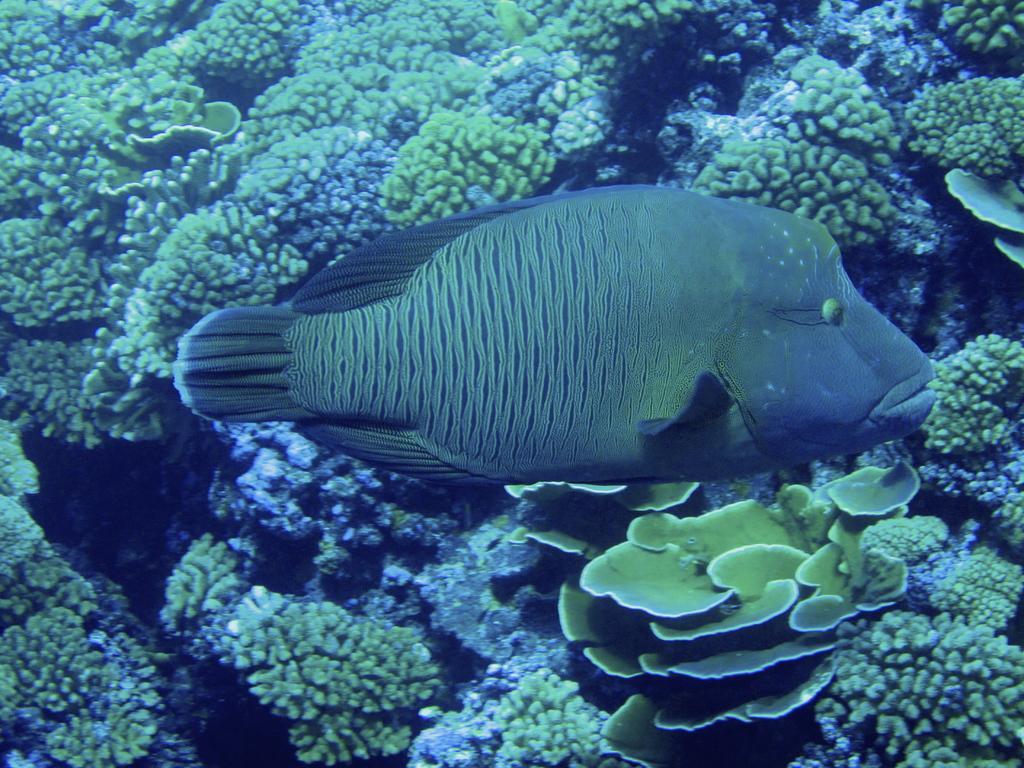Describe this image in one or two sentences. The picture is clicked inside water. In the center of the picture there is a fish. In the background there are water plants. 